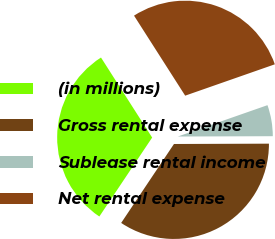Convert chart. <chart><loc_0><loc_0><loc_500><loc_500><pie_chart><fcel>(in millions)<fcel>Gross rental expense<fcel>Sublease rental income<fcel>Net rental expense<nl><fcel>31.57%<fcel>34.44%<fcel>5.3%<fcel>28.7%<nl></chart> 